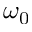Convert formula to latex. <formula><loc_0><loc_0><loc_500><loc_500>\omega _ { 0 }</formula> 